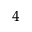<formula> <loc_0><loc_0><loc_500><loc_500>^ { 4 }</formula> 